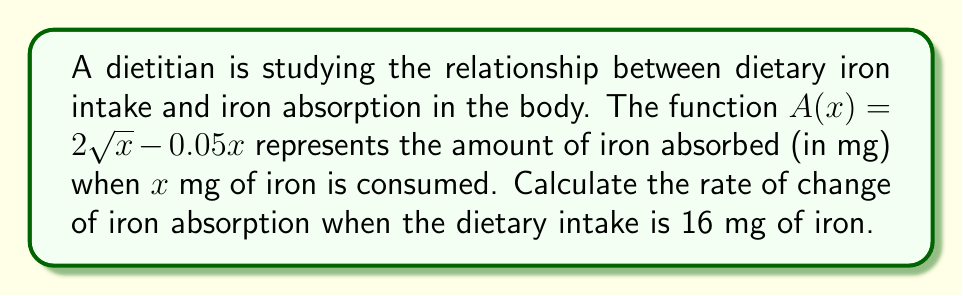Show me your answer to this math problem. To find the rate of change of iron absorption at a specific point, we need to calculate the derivative of the absorption function $A(x)$ and then evaluate it at the given point.

1) The absorption function is $A(x) = 2\sqrt{x} - 0.05x$

2) To find the derivative, we use the power rule and the constant multiple rule:
   $$\frac{d}{dx}(2\sqrt{x}) = 2 \cdot \frac{1}{2}x^{-1/2} = x^{-1/2}$$
   $$\frac{d}{dx}(-0.05x) = -0.05$$

3) Combining these, we get the derivative function:
   $$A'(x) = x^{-1/2} - 0.05$$

4) Now, we need to evaluate this at $x = 16$:
   $$A'(16) = 16^{-1/2} - 0.05$$

5) Simplify:
   $$A'(16) = \frac{1}{4} - 0.05 = 0.25 - 0.05 = 0.2$$

Therefore, when the dietary intake is 16 mg of iron, the rate of change of iron absorption is 0.2 mg per mg of iron consumed.
Answer: $0.2$ mg/mg 